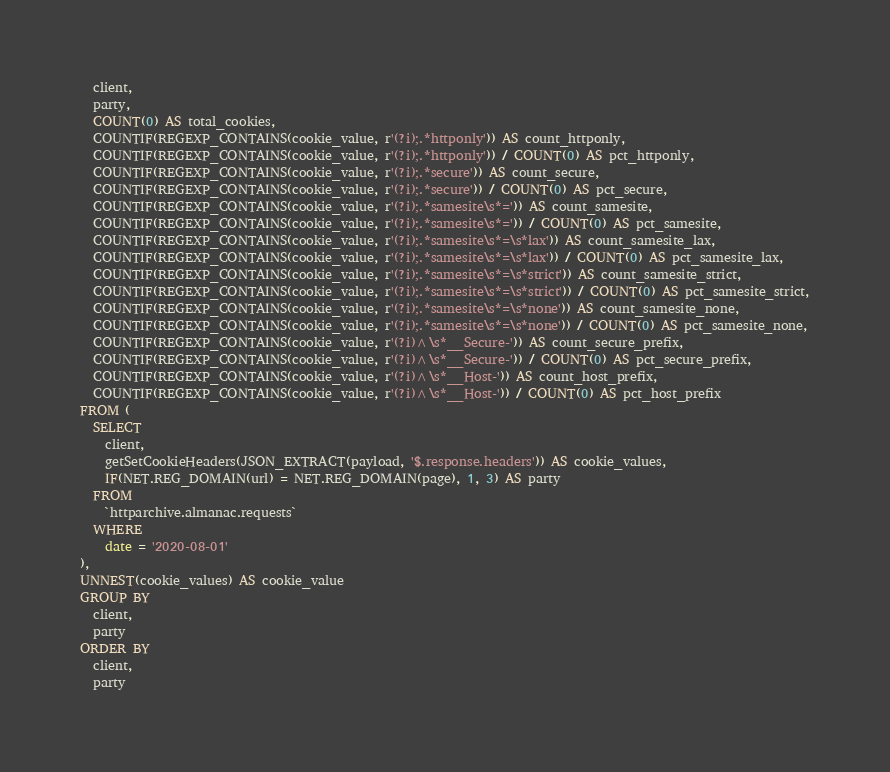Convert code to text. <code><loc_0><loc_0><loc_500><loc_500><_SQL_>  client,
  party,
  COUNT(0) AS total_cookies,
  COUNTIF(REGEXP_CONTAINS(cookie_value, r'(?i);.*httponly')) AS count_httponly,
  COUNTIF(REGEXP_CONTAINS(cookie_value, r'(?i);.*httponly')) / COUNT(0) AS pct_httponly,
  COUNTIF(REGEXP_CONTAINS(cookie_value, r'(?i);.*secure')) AS count_secure,
  COUNTIF(REGEXP_CONTAINS(cookie_value, r'(?i);.*secure')) / COUNT(0) AS pct_secure,
  COUNTIF(REGEXP_CONTAINS(cookie_value, r'(?i);.*samesite\s*=')) AS count_samesite,
  COUNTIF(REGEXP_CONTAINS(cookie_value, r'(?i);.*samesite\s*=')) / COUNT(0) AS pct_samesite,
  COUNTIF(REGEXP_CONTAINS(cookie_value, r'(?i);.*samesite\s*=\s*lax')) AS count_samesite_lax,
  COUNTIF(REGEXP_CONTAINS(cookie_value, r'(?i);.*samesite\s*=\s*lax')) / COUNT(0) AS pct_samesite_lax,
  COUNTIF(REGEXP_CONTAINS(cookie_value, r'(?i);.*samesite\s*=\s*strict')) AS count_samesite_strict,
  COUNTIF(REGEXP_CONTAINS(cookie_value, r'(?i);.*samesite\s*=\s*strict')) / COUNT(0) AS pct_samesite_strict,
  COUNTIF(REGEXP_CONTAINS(cookie_value, r'(?i);.*samesite\s*=\s*none')) AS count_samesite_none,
  COUNTIF(REGEXP_CONTAINS(cookie_value, r'(?i);.*samesite\s*=\s*none')) / COUNT(0) AS pct_samesite_none,
  COUNTIF(REGEXP_CONTAINS(cookie_value, r'(?i)^\s*__Secure-')) AS count_secure_prefix,
  COUNTIF(REGEXP_CONTAINS(cookie_value, r'(?i)^\s*__Secure-')) / COUNT(0) AS pct_secure_prefix,
  COUNTIF(REGEXP_CONTAINS(cookie_value, r'(?i)^\s*__Host-')) AS count_host_prefix,
  COUNTIF(REGEXP_CONTAINS(cookie_value, r'(?i)^\s*__Host-')) / COUNT(0) AS pct_host_prefix
FROM (
  SELECT
    client,
    getSetCookieHeaders(JSON_EXTRACT(payload, '$.response.headers')) AS cookie_values,
    IF(NET.REG_DOMAIN(url) = NET.REG_DOMAIN(page), 1, 3) AS party
  FROM
    `httparchive.almanac.requests`
  WHERE
    date = '2020-08-01'
),
UNNEST(cookie_values) AS cookie_value
GROUP BY
  client,
  party
ORDER BY
  client,
  party
</code> 